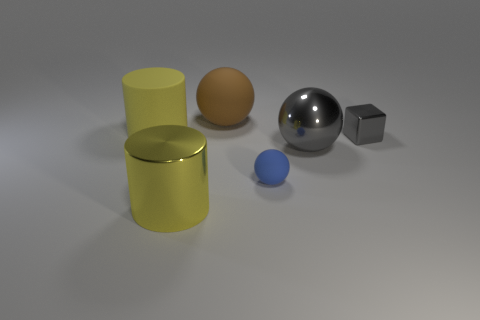What is the color of the rubber sphere in front of the metallic cube?
Ensure brevity in your answer.  Blue. Are there more brown balls that are to the right of the small blue matte sphere than tiny brown blocks?
Offer a very short reply. No. Does the small ball have the same material as the large gray ball?
Offer a terse response. No. What number of other objects are there of the same shape as the blue matte thing?
Your answer should be very brief. 2. Is there anything else that has the same material as the blue object?
Offer a very short reply. Yes. There is a matte ball in front of the cylinder that is behind the gray metal object on the right side of the big metallic ball; what color is it?
Keep it short and to the point. Blue. There is a yellow object that is behind the big metallic ball; is it the same shape as the big yellow shiny thing?
Provide a short and direct response. Yes. What number of cylinders are there?
Give a very brief answer. 2. How many yellow matte cylinders are the same size as the yellow metal thing?
Give a very brief answer. 1. What is the material of the large gray thing?
Keep it short and to the point. Metal. 